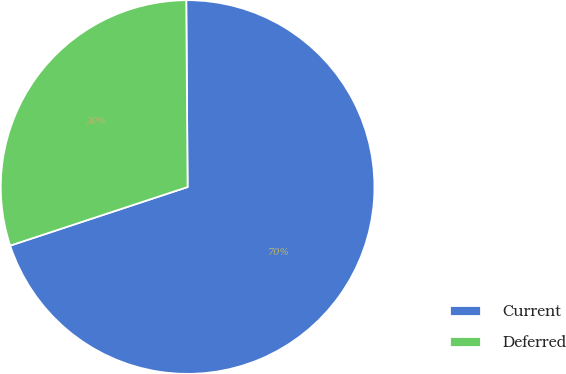Convert chart. <chart><loc_0><loc_0><loc_500><loc_500><pie_chart><fcel>Current<fcel>Deferred<nl><fcel>70.04%<fcel>29.96%<nl></chart> 